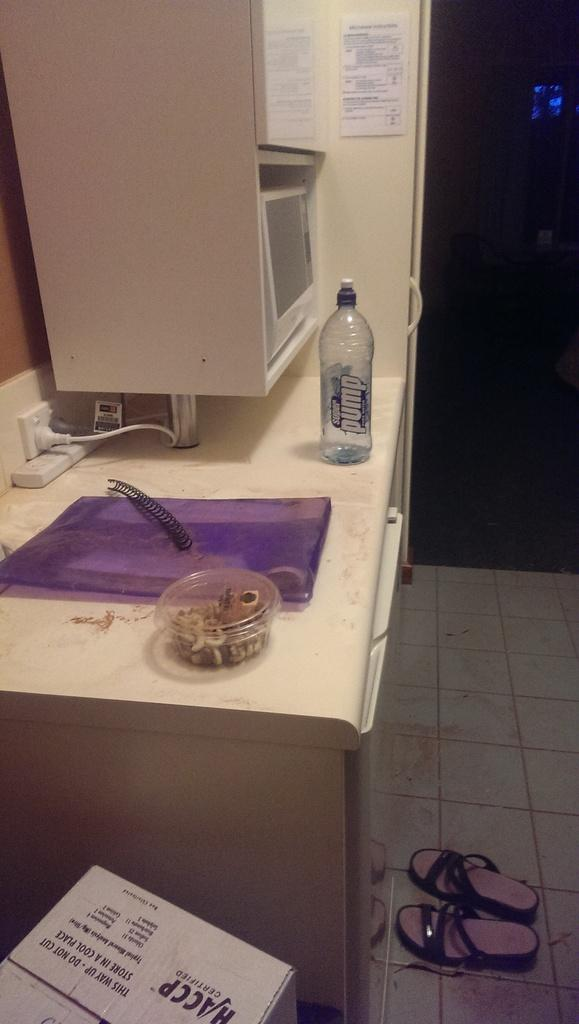Provide a one-sentence caption for the provided image. The counter has a purple mat and a pump water bottle on it. 